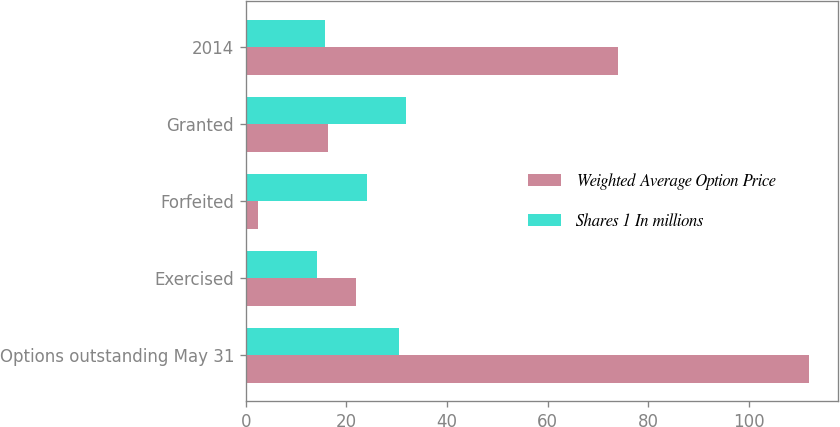Convert chart. <chart><loc_0><loc_0><loc_500><loc_500><stacked_bar_chart><ecel><fcel>Options outstanding May 31<fcel>Exercised<fcel>Forfeited<fcel>Granted<fcel>2014<nl><fcel>Weighted Average Option Price<fcel>112<fcel>22<fcel>2.5<fcel>16.3<fcel>74<nl><fcel>Shares 1 In millions<fcel>30.38<fcel>14.15<fcel>24.17<fcel>31.77<fcel>15.71<nl></chart> 